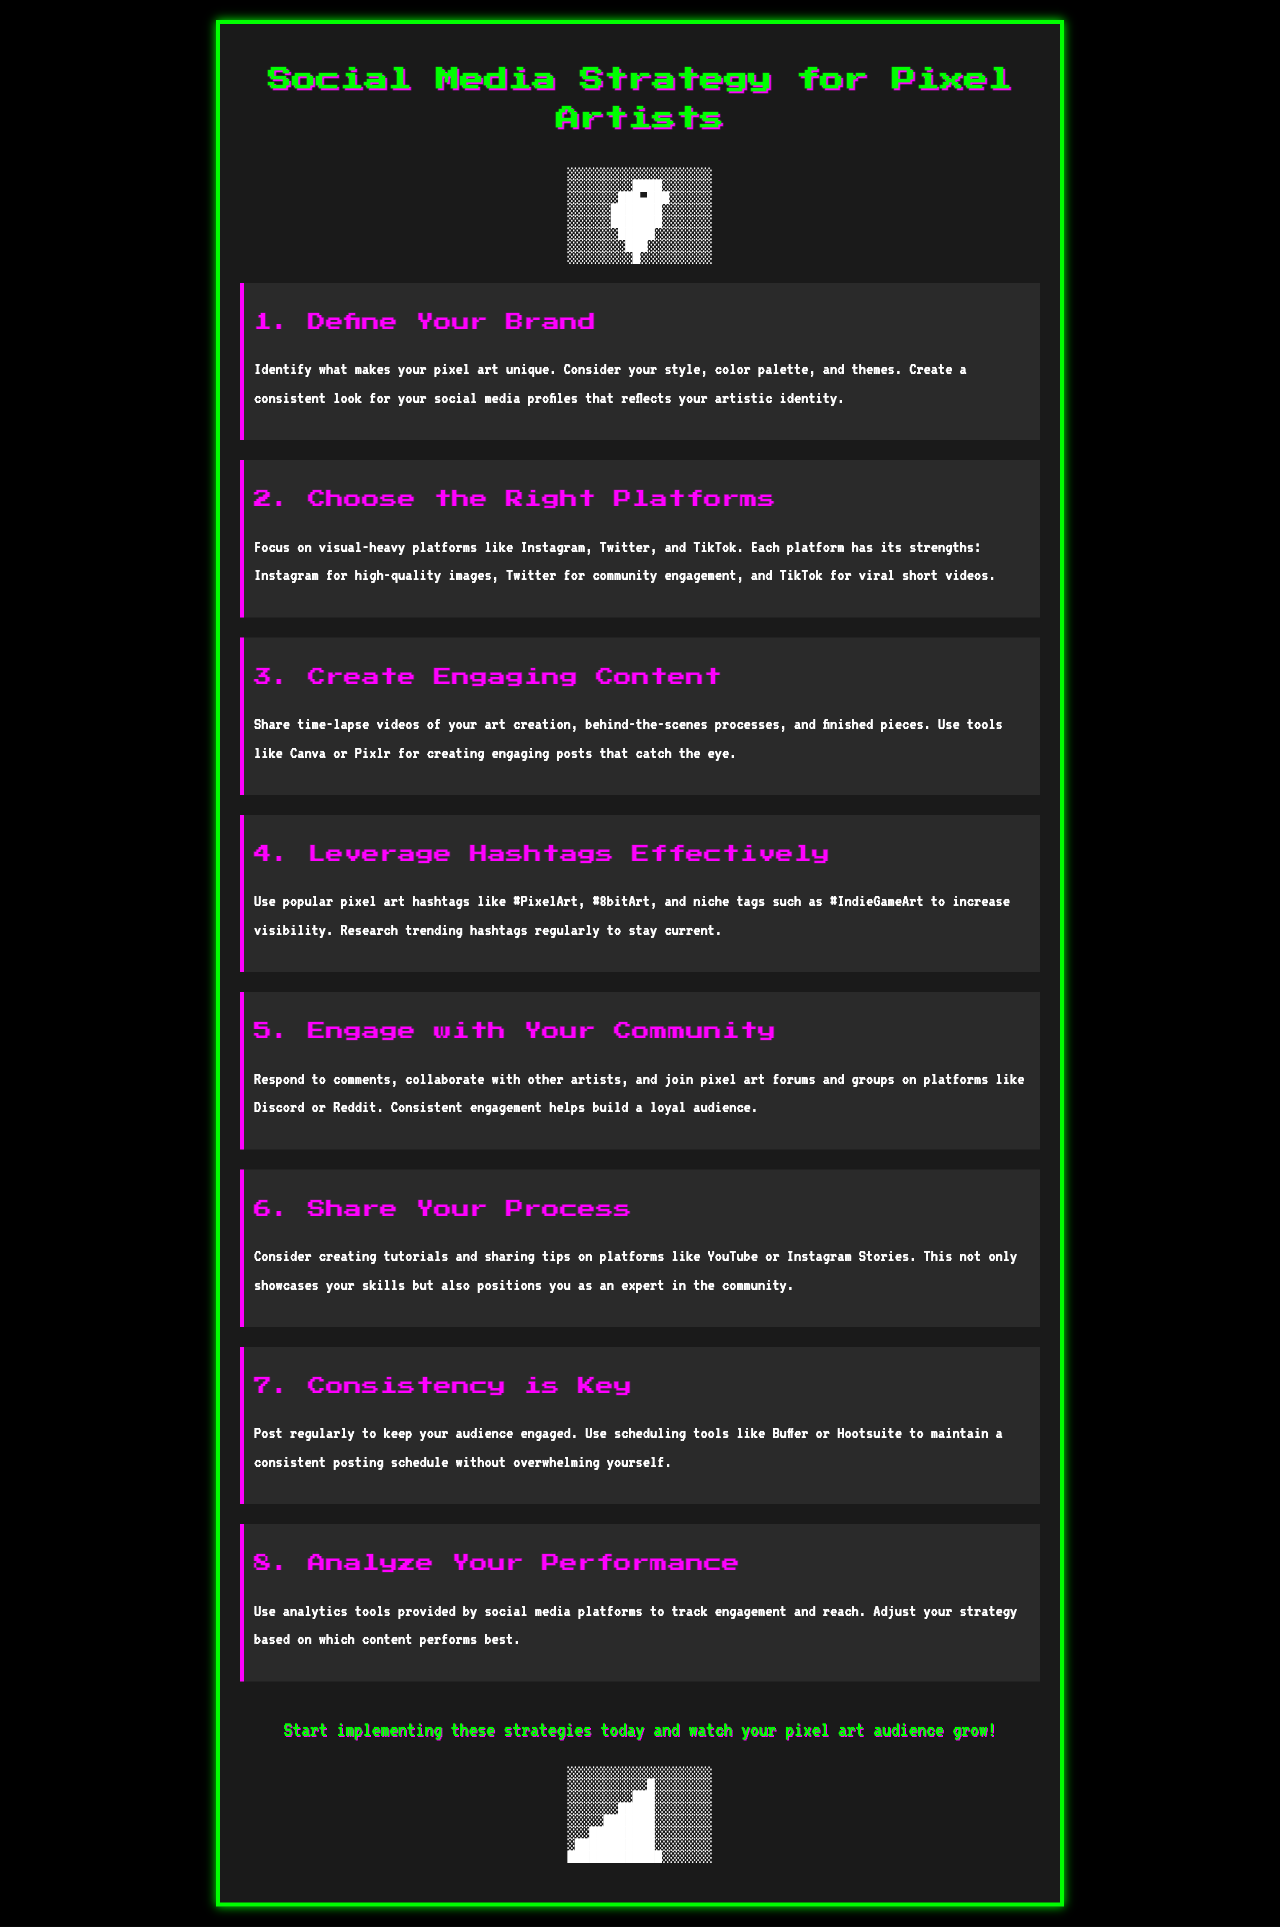What is the title of the brochure? The title is the main heading stated at the top of the document.
Answer: Social Media Strategy for Pixel Artists How many main sections are there in the document? The total sections are listed numerically in the headings throughout the document.
Answer: 8 Which color is used for the main title text? The color of the main title is specifically mentioned in the styling of the document.
Answer: Bright green What social media platforms should pixel artists focus on? The recommended platforms for pixel artists are mentioned in the second section of the document.
Answer: Instagram, Twitter, TikTok What is a recommended tool for scheduling posts? A specific tool for post scheduling is mentioned in the seventh section as part of maintaining a consistent schedule.
Answer: Buffer What type of content should be shared according to the document? The document suggests specific types of content that artists can create and share to engage their audience.
Answer: Time-lapse videos What is a key aspect of community engagement mentioned? The document highlights a particular activity as crucial for building a loyal audience in the fifth section.
Answer: Respond to comments What should artists analyze to improve their strategy? The document mentions a specific element that artists should track to refine their approach.
Answer: Performance 